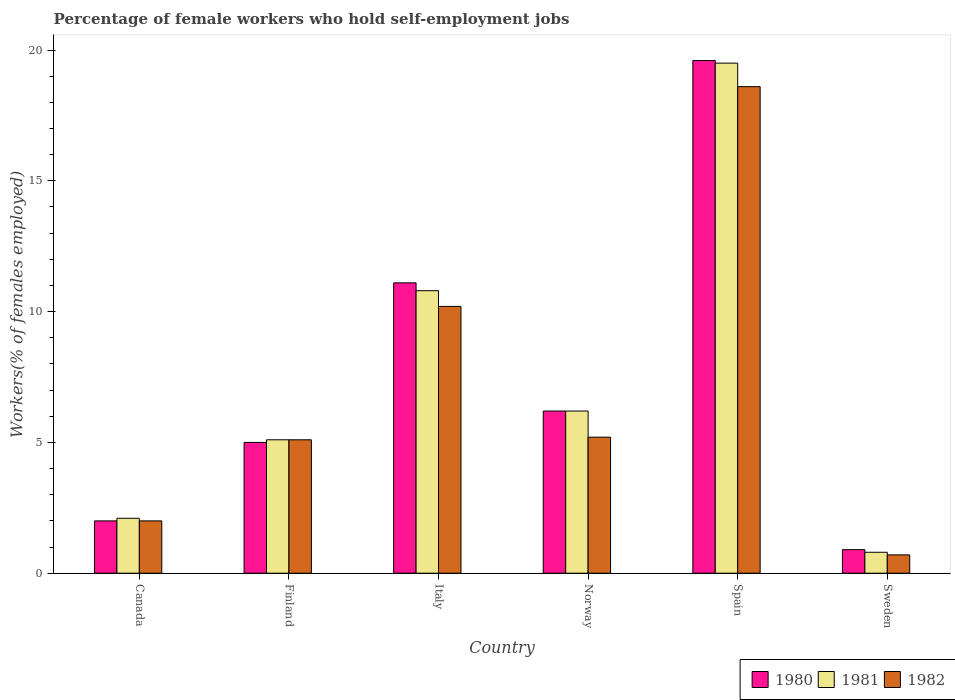Are the number of bars per tick equal to the number of legend labels?
Provide a succinct answer. Yes. Are the number of bars on each tick of the X-axis equal?
Offer a very short reply. Yes. How many bars are there on the 4th tick from the right?
Offer a very short reply. 3. What is the percentage of self-employed female workers in 1982 in Italy?
Provide a short and direct response. 10.2. Across all countries, what is the maximum percentage of self-employed female workers in 1982?
Offer a terse response. 18.6. Across all countries, what is the minimum percentage of self-employed female workers in 1982?
Keep it short and to the point. 0.7. In which country was the percentage of self-employed female workers in 1982 maximum?
Ensure brevity in your answer.  Spain. In which country was the percentage of self-employed female workers in 1981 minimum?
Offer a very short reply. Sweden. What is the total percentage of self-employed female workers in 1981 in the graph?
Give a very brief answer. 44.5. What is the difference between the percentage of self-employed female workers in 1981 in Italy and that in Spain?
Offer a terse response. -8.7. What is the difference between the percentage of self-employed female workers in 1982 in Italy and the percentage of self-employed female workers in 1981 in Canada?
Your answer should be very brief. 8.1. What is the average percentage of self-employed female workers in 1980 per country?
Offer a very short reply. 7.47. What is the difference between the percentage of self-employed female workers of/in 1981 and percentage of self-employed female workers of/in 1980 in Canada?
Offer a terse response. 0.1. What is the ratio of the percentage of self-employed female workers in 1982 in Canada to that in Sweden?
Offer a terse response. 2.86. Is the percentage of self-employed female workers in 1982 in Norway less than that in Sweden?
Ensure brevity in your answer.  No. Is the difference between the percentage of self-employed female workers in 1981 in Finland and Spain greater than the difference between the percentage of self-employed female workers in 1980 in Finland and Spain?
Keep it short and to the point. Yes. What is the difference between the highest and the second highest percentage of self-employed female workers in 1982?
Your answer should be compact. 8.4. What is the difference between the highest and the lowest percentage of self-employed female workers in 1980?
Provide a succinct answer. 18.7. In how many countries, is the percentage of self-employed female workers in 1980 greater than the average percentage of self-employed female workers in 1980 taken over all countries?
Provide a short and direct response. 2. Is it the case that in every country, the sum of the percentage of self-employed female workers in 1980 and percentage of self-employed female workers in 1981 is greater than the percentage of self-employed female workers in 1982?
Ensure brevity in your answer.  Yes. What is the difference between two consecutive major ticks on the Y-axis?
Provide a succinct answer. 5. Are the values on the major ticks of Y-axis written in scientific E-notation?
Offer a very short reply. No. Does the graph contain grids?
Your answer should be very brief. No. Where does the legend appear in the graph?
Offer a very short reply. Bottom right. How many legend labels are there?
Your response must be concise. 3. What is the title of the graph?
Your response must be concise. Percentage of female workers who hold self-employment jobs. What is the label or title of the X-axis?
Your response must be concise. Country. What is the label or title of the Y-axis?
Your response must be concise. Workers(% of females employed). What is the Workers(% of females employed) of 1980 in Canada?
Make the answer very short. 2. What is the Workers(% of females employed) in 1981 in Canada?
Make the answer very short. 2.1. What is the Workers(% of females employed) in 1981 in Finland?
Ensure brevity in your answer.  5.1. What is the Workers(% of females employed) of 1982 in Finland?
Provide a short and direct response. 5.1. What is the Workers(% of females employed) of 1980 in Italy?
Ensure brevity in your answer.  11.1. What is the Workers(% of females employed) of 1981 in Italy?
Your response must be concise. 10.8. What is the Workers(% of females employed) of 1982 in Italy?
Offer a terse response. 10.2. What is the Workers(% of females employed) of 1980 in Norway?
Your response must be concise. 6.2. What is the Workers(% of females employed) of 1981 in Norway?
Keep it short and to the point. 6.2. What is the Workers(% of females employed) of 1982 in Norway?
Your answer should be compact. 5.2. What is the Workers(% of females employed) of 1980 in Spain?
Your answer should be compact. 19.6. What is the Workers(% of females employed) of 1981 in Spain?
Keep it short and to the point. 19.5. What is the Workers(% of females employed) of 1982 in Spain?
Make the answer very short. 18.6. What is the Workers(% of females employed) of 1980 in Sweden?
Provide a succinct answer. 0.9. What is the Workers(% of females employed) in 1981 in Sweden?
Offer a very short reply. 0.8. What is the Workers(% of females employed) of 1982 in Sweden?
Give a very brief answer. 0.7. Across all countries, what is the maximum Workers(% of females employed) in 1980?
Provide a succinct answer. 19.6. Across all countries, what is the maximum Workers(% of females employed) of 1982?
Make the answer very short. 18.6. Across all countries, what is the minimum Workers(% of females employed) in 1980?
Provide a succinct answer. 0.9. Across all countries, what is the minimum Workers(% of females employed) of 1981?
Ensure brevity in your answer.  0.8. Across all countries, what is the minimum Workers(% of females employed) of 1982?
Make the answer very short. 0.7. What is the total Workers(% of females employed) of 1980 in the graph?
Your response must be concise. 44.8. What is the total Workers(% of females employed) of 1981 in the graph?
Your answer should be very brief. 44.5. What is the total Workers(% of females employed) of 1982 in the graph?
Ensure brevity in your answer.  41.8. What is the difference between the Workers(% of females employed) in 1980 in Canada and that in Finland?
Make the answer very short. -3. What is the difference between the Workers(% of females employed) of 1980 in Canada and that in Norway?
Make the answer very short. -4.2. What is the difference between the Workers(% of females employed) in 1980 in Canada and that in Spain?
Your answer should be compact. -17.6. What is the difference between the Workers(% of females employed) of 1981 in Canada and that in Spain?
Your answer should be very brief. -17.4. What is the difference between the Workers(% of females employed) in 1982 in Canada and that in Spain?
Ensure brevity in your answer.  -16.6. What is the difference between the Workers(% of females employed) of 1980 in Canada and that in Sweden?
Offer a terse response. 1.1. What is the difference between the Workers(% of females employed) of 1982 in Finland and that in Italy?
Your answer should be very brief. -5.1. What is the difference between the Workers(% of females employed) in 1980 in Finland and that in Norway?
Give a very brief answer. -1.2. What is the difference between the Workers(% of females employed) of 1980 in Finland and that in Spain?
Provide a succinct answer. -14.6. What is the difference between the Workers(% of females employed) in 1981 in Finland and that in Spain?
Provide a succinct answer. -14.4. What is the difference between the Workers(% of females employed) of 1982 in Finland and that in Sweden?
Keep it short and to the point. 4.4. What is the difference between the Workers(% of females employed) in 1982 in Italy and that in Norway?
Give a very brief answer. 5. What is the difference between the Workers(% of females employed) in 1981 in Italy and that in Spain?
Keep it short and to the point. -8.7. What is the difference between the Workers(% of females employed) in 1982 in Italy and that in Sweden?
Offer a very short reply. 9.5. What is the difference between the Workers(% of females employed) of 1982 in Norway and that in Spain?
Your response must be concise. -13.4. What is the difference between the Workers(% of females employed) of 1980 in Norway and that in Sweden?
Ensure brevity in your answer.  5.3. What is the difference between the Workers(% of females employed) in 1981 in Norway and that in Sweden?
Offer a terse response. 5.4. What is the difference between the Workers(% of females employed) in 1982 in Norway and that in Sweden?
Keep it short and to the point. 4.5. What is the difference between the Workers(% of females employed) of 1981 in Spain and that in Sweden?
Make the answer very short. 18.7. What is the difference between the Workers(% of females employed) of 1982 in Spain and that in Sweden?
Ensure brevity in your answer.  17.9. What is the difference between the Workers(% of females employed) in 1980 in Canada and the Workers(% of females employed) in 1981 in Italy?
Offer a very short reply. -8.8. What is the difference between the Workers(% of females employed) of 1981 in Canada and the Workers(% of females employed) of 1982 in Italy?
Keep it short and to the point. -8.1. What is the difference between the Workers(% of females employed) in 1980 in Canada and the Workers(% of females employed) in 1981 in Spain?
Ensure brevity in your answer.  -17.5. What is the difference between the Workers(% of females employed) of 1980 in Canada and the Workers(% of females employed) of 1982 in Spain?
Make the answer very short. -16.6. What is the difference between the Workers(% of females employed) in 1981 in Canada and the Workers(% of females employed) in 1982 in Spain?
Offer a terse response. -16.5. What is the difference between the Workers(% of females employed) of 1981 in Canada and the Workers(% of females employed) of 1982 in Sweden?
Offer a terse response. 1.4. What is the difference between the Workers(% of females employed) in 1980 in Finland and the Workers(% of females employed) in 1982 in Italy?
Your answer should be compact. -5.2. What is the difference between the Workers(% of females employed) of 1980 in Finland and the Workers(% of females employed) of 1981 in Norway?
Offer a terse response. -1.2. What is the difference between the Workers(% of females employed) of 1980 in Finland and the Workers(% of females employed) of 1982 in Norway?
Your answer should be very brief. -0.2. What is the difference between the Workers(% of females employed) in 1981 in Finland and the Workers(% of females employed) in 1982 in Norway?
Your answer should be compact. -0.1. What is the difference between the Workers(% of females employed) of 1981 in Finland and the Workers(% of females employed) of 1982 in Spain?
Your answer should be compact. -13.5. What is the difference between the Workers(% of females employed) of 1980 in Finland and the Workers(% of females employed) of 1981 in Sweden?
Your answer should be very brief. 4.2. What is the difference between the Workers(% of females employed) of 1980 in Finland and the Workers(% of females employed) of 1982 in Sweden?
Provide a short and direct response. 4.3. What is the difference between the Workers(% of females employed) in 1981 in Finland and the Workers(% of females employed) in 1982 in Sweden?
Your answer should be very brief. 4.4. What is the difference between the Workers(% of females employed) of 1980 in Italy and the Workers(% of females employed) of 1981 in Norway?
Ensure brevity in your answer.  4.9. What is the difference between the Workers(% of females employed) in 1981 in Italy and the Workers(% of females employed) in 1982 in Spain?
Offer a terse response. -7.8. What is the difference between the Workers(% of females employed) in 1980 in Italy and the Workers(% of females employed) in 1981 in Sweden?
Your answer should be compact. 10.3. What is the difference between the Workers(% of females employed) in 1980 in Norway and the Workers(% of females employed) in 1981 in Spain?
Offer a very short reply. -13.3. What is the difference between the Workers(% of females employed) of 1981 in Norway and the Workers(% of females employed) of 1982 in Spain?
Make the answer very short. -12.4. What is the difference between the Workers(% of females employed) of 1980 in Norway and the Workers(% of females employed) of 1982 in Sweden?
Offer a terse response. 5.5. What is the difference between the Workers(% of females employed) of 1980 in Spain and the Workers(% of females employed) of 1981 in Sweden?
Offer a terse response. 18.8. What is the difference between the Workers(% of females employed) of 1980 in Spain and the Workers(% of females employed) of 1982 in Sweden?
Provide a succinct answer. 18.9. What is the average Workers(% of females employed) of 1980 per country?
Make the answer very short. 7.47. What is the average Workers(% of females employed) of 1981 per country?
Keep it short and to the point. 7.42. What is the average Workers(% of females employed) of 1982 per country?
Your response must be concise. 6.97. What is the difference between the Workers(% of females employed) of 1980 and Workers(% of females employed) of 1982 in Canada?
Your answer should be very brief. 0. What is the difference between the Workers(% of females employed) in 1981 and Workers(% of females employed) in 1982 in Canada?
Provide a succinct answer. 0.1. What is the difference between the Workers(% of females employed) of 1980 and Workers(% of females employed) of 1981 in Finland?
Give a very brief answer. -0.1. What is the difference between the Workers(% of females employed) of 1980 and Workers(% of females employed) of 1982 in Finland?
Offer a very short reply. -0.1. What is the difference between the Workers(% of females employed) in 1981 and Workers(% of females employed) in 1982 in Finland?
Ensure brevity in your answer.  0. What is the difference between the Workers(% of females employed) in 1980 and Workers(% of females employed) in 1981 in Italy?
Provide a succinct answer. 0.3. What is the difference between the Workers(% of females employed) in 1980 and Workers(% of females employed) in 1982 in Italy?
Offer a terse response. 0.9. What is the difference between the Workers(% of females employed) of 1980 and Workers(% of females employed) of 1981 in Norway?
Give a very brief answer. 0. What is the difference between the Workers(% of females employed) in 1980 and Workers(% of females employed) in 1981 in Sweden?
Keep it short and to the point. 0.1. What is the ratio of the Workers(% of females employed) of 1980 in Canada to that in Finland?
Ensure brevity in your answer.  0.4. What is the ratio of the Workers(% of females employed) in 1981 in Canada to that in Finland?
Offer a terse response. 0.41. What is the ratio of the Workers(% of females employed) of 1982 in Canada to that in Finland?
Keep it short and to the point. 0.39. What is the ratio of the Workers(% of females employed) in 1980 in Canada to that in Italy?
Ensure brevity in your answer.  0.18. What is the ratio of the Workers(% of females employed) of 1981 in Canada to that in Italy?
Your answer should be compact. 0.19. What is the ratio of the Workers(% of females employed) in 1982 in Canada to that in Italy?
Your response must be concise. 0.2. What is the ratio of the Workers(% of females employed) in 1980 in Canada to that in Norway?
Give a very brief answer. 0.32. What is the ratio of the Workers(% of females employed) in 1981 in Canada to that in Norway?
Ensure brevity in your answer.  0.34. What is the ratio of the Workers(% of females employed) in 1982 in Canada to that in Norway?
Ensure brevity in your answer.  0.38. What is the ratio of the Workers(% of females employed) of 1980 in Canada to that in Spain?
Provide a short and direct response. 0.1. What is the ratio of the Workers(% of females employed) of 1981 in Canada to that in Spain?
Offer a very short reply. 0.11. What is the ratio of the Workers(% of females employed) in 1982 in Canada to that in Spain?
Give a very brief answer. 0.11. What is the ratio of the Workers(% of females employed) of 1980 in Canada to that in Sweden?
Give a very brief answer. 2.22. What is the ratio of the Workers(% of females employed) of 1981 in Canada to that in Sweden?
Offer a very short reply. 2.62. What is the ratio of the Workers(% of females employed) of 1982 in Canada to that in Sweden?
Provide a succinct answer. 2.86. What is the ratio of the Workers(% of females employed) of 1980 in Finland to that in Italy?
Offer a very short reply. 0.45. What is the ratio of the Workers(% of females employed) in 1981 in Finland to that in Italy?
Your response must be concise. 0.47. What is the ratio of the Workers(% of females employed) in 1980 in Finland to that in Norway?
Ensure brevity in your answer.  0.81. What is the ratio of the Workers(% of females employed) of 1981 in Finland to that in Norway?
Provide a succinct answer. 0.82. What is the ratio of the Workers(% of females employed) of 1982 in Finland to that in Norway?
Provide a short and direct response. 0.98. What is the ratio of the Workers(% of females employed) in 1980 in Finland to that in Spain?
Your answer should be very brief. 0.26. What is the ratio of the Workers(% of females employed) of 1981 in Finland to that in Spain?
Your answer should be very brief. 0.26. What is the ratio of the Workers(% of females employed) of 1982 in Finland to that in Spain?
Provide a short and direct response. 0.27. What is the ratio of the Workers(% of females employed) of 1980 in Finland to that in Sweden?
Provide a short and direct response. 5.56. What is the ratio of the Workers(% of females employed) in 1981 in Finland to that in Sweden?
Offer a very short reply. 6.38. What is the ratio of the Workers(% of females employed) in 1982 in Finland to that in Sweden?
Give a very brief answer. 7.29. What is the ratio of the Workers(% of females employed) in 1980 in Italy to that in Norway?
Ensure brevity in your answer.  1.79. What is the ratio of the Workers(% of females employed) in 1981 in Italy to that in Norway?
Your response must be concise. 1.74. What is the ratio of the Workers(% of females employed) in 1982 in Italy to that in Norway?
Your answer should be very brief. 1.96. What is the ratio of the Workers(% of females employed) of 1980 in Italy to that in Spain?
Your response must be concise. 0.57. What is the ratio of the Workers(% of females employed) in 1981 in Italy to that in Spain?
Your answer should be very brief. 0.55. What is the ratio of the Workers(% of females employed) of 1982 in Italy to that in Spain?
Keep it short and to the point. 0.55. What is the ratio of the Workers(% of females employed) of 1980 in Italy to that in Sweden?
Give a very brief answer. 12.33. What is the ratio of the Workers(% of females employed) in 1982 in Italy to that in Sweden?
Offer a terse response. 14.57. What is the ratio of the Workers(% of females employed) in 1980 in Norway to that in Spain?
Your response must be concise. 0.32. What is the ratio of the Workers(% of females employed) in 1981 in Norway to that in Spain?
Ensure brevity in your answer.  0.32. What is the ratio of the Workers(% of females employed) in 1982 in Norway to that in Spain?
Your response must be concise. 0.28. What is the ratio of the Workers(% of females employed) of 1980 in Norway to that in Sweden?
Offer a terse response. 6.89. What is the ratio of the Workers(% of females employed) of 1981 in Norway to that in Sweden?
Your answer should be compact. 7.75. What is the ratio of the Workers(% of females employed) of 1982 in Norway to that in Sweden?
Your answer should be compact. 7.43. What is the ratio of the Workers(% of females employed) of 1980 in Spain to that in Sweden?
Ensure brevity in your answer.  21.78. What is the ratio of the Workers(% of females employed) of 1981 in Spain to that in Sweden?
Provide a succinct answer. 24.38. What is the ratio of the Workers(% of females employed) of 1982 in Spain to that in Sweden?
Provide a succinct answer. 26.57. What is the difference between the highest and the second highest Workers(% of females employed) of 1980?
Your answer should be very brief. 8.5. What is the difference between the highest and the second highest Workers(% of females employed) in 1982?
Your answer should be very brief. 8.4. What is the difference between the highest and the lowest Workers(% of females employed) in 1980?
Offer a very short reply. 18.7. What is the difference between the highest and the lowest Workers(% of females employed) of 1981?
Provide a short and direct response. 18.7. 